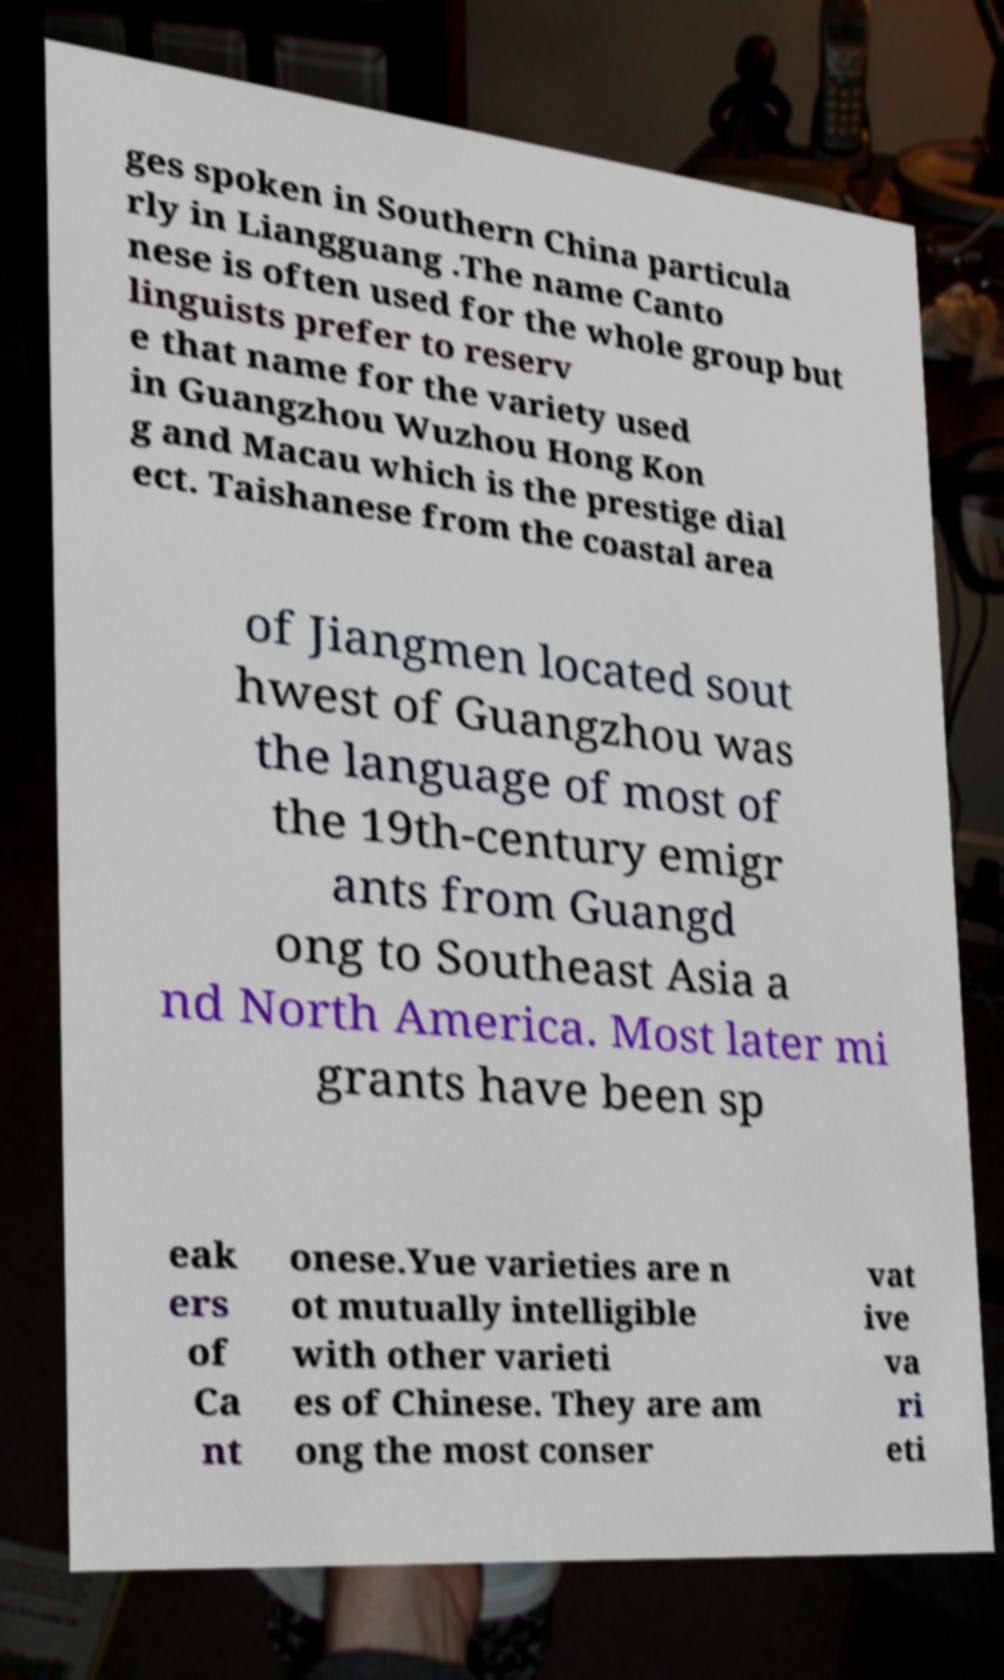I need the written content from this picture converted into text. Can you do that? ges spoken in Southern China particula rly in Liangguang .The name Canto nese is often used for the whole group but linguists prefer to reserv e that name for the variety used in Guangzhou Wuzhou Hong Kon g and Macau which is the prestige dial ect. Taishanese from the coastal area of Jiangmen located sout hwest of Guangzhou was the language of most of the 19th-century emigr ants from Guangd ong to Southeast Asia a nd North America. Most later mi grants have been sp eak ers of Ca nt onese.Yue varieties are n ot mutually intelligible with other varieti es of Chinese. They are am ong the most conser vat ive va ri eti 